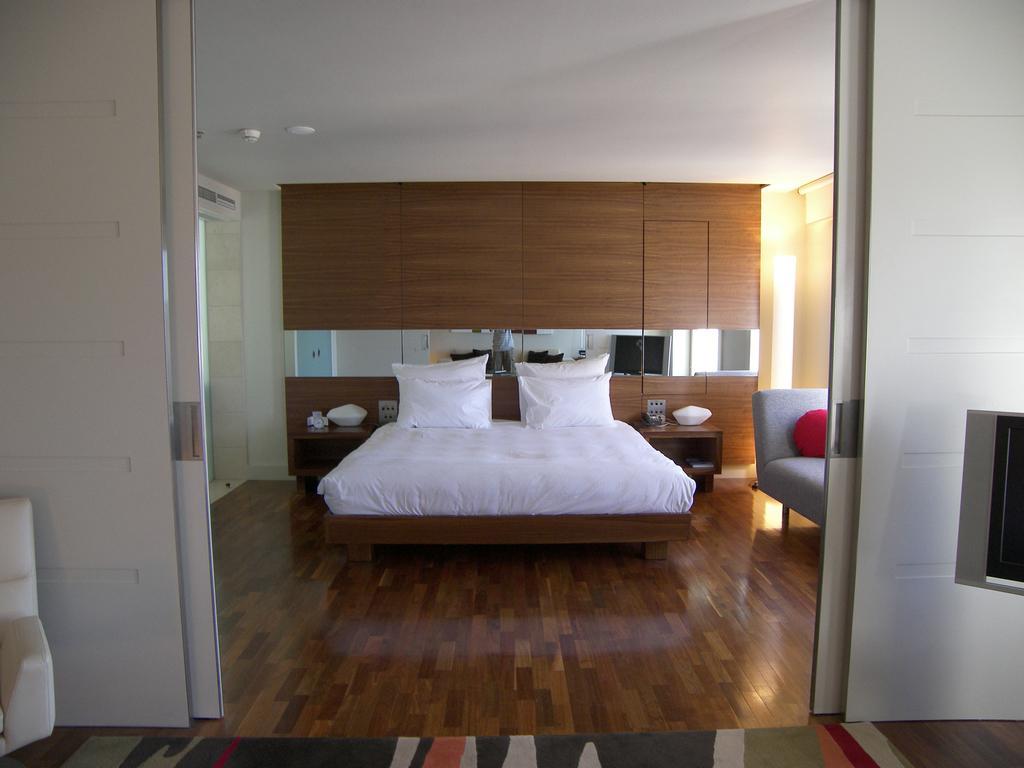Describe this image in one or two sentences. In the middle it is a bed which is in white color there are pillows on it. At the top it's a roof. 